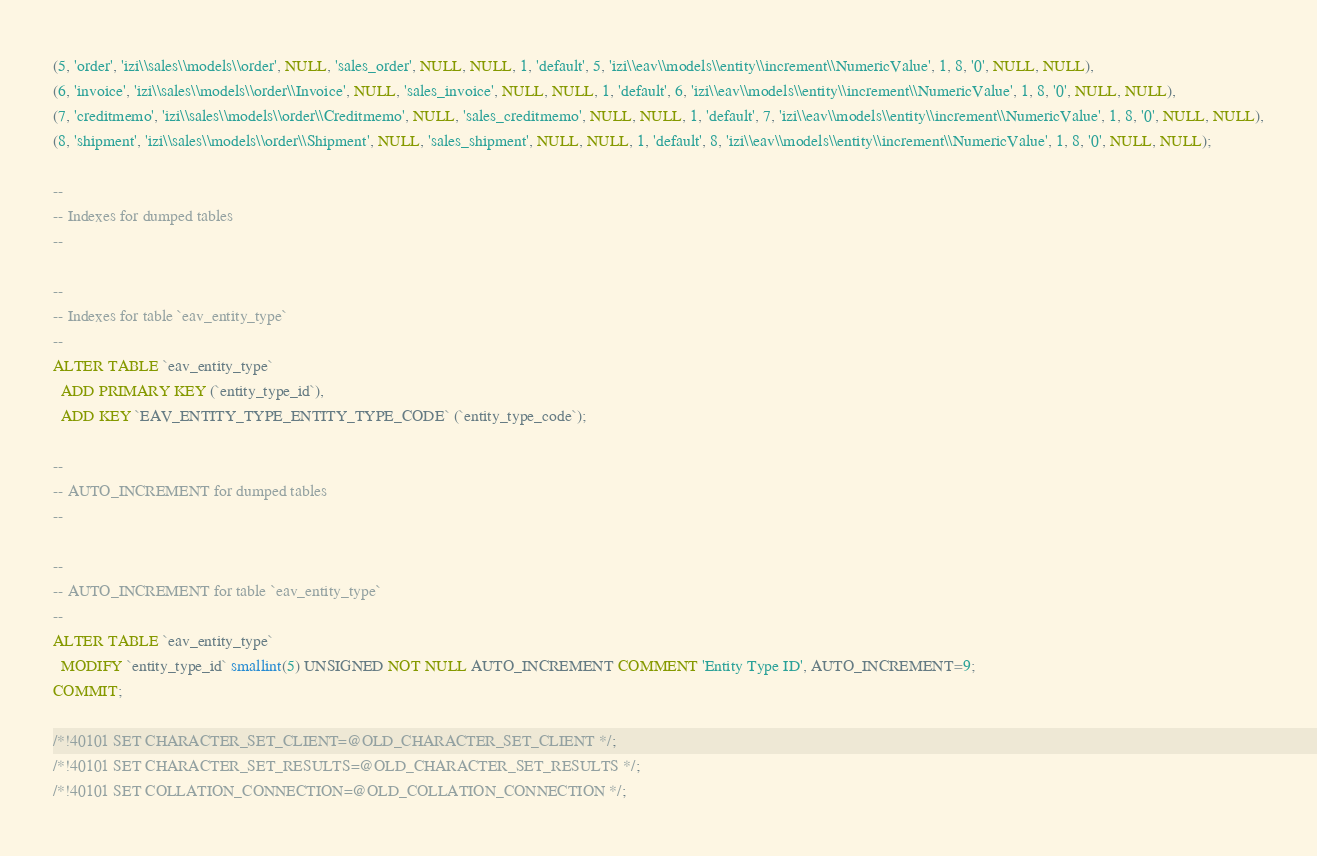<code> <loc_0><loc_0><loc_500><loc_500><_SQL_>(5, 'order', 'izi\\sales\\models\\order', NULL, 'sales_order', NULL, NULL, 1, 'default', 5, 'izi\\eav\\models\\entity\\increment\\NumericValue', 1, 8, '0', NULL, NULL),
(6, 'invoice', 'izi\\sales\\models\\order\\Invoice', NULL, 'sales_invoice', NULL, NULL, 1, 'default', 6, 'izi\\eav\\models\\entity\\increment\\NumericValue', 1, 8, '0', NULL, NULL),
(7, 'creditmemo', 'izi\\sales\\models\\order\\Creditmemo', NULL, 'sales_creditmemo', NULL, NULL, 1, 'default', 7, 'izi\\eav\\models\\entity\\increment\\NumericValue', 1, 8, '0', NULL, NULL),
(8, 'shipment', 'izi\\sales\\models\\order\\Shipment', NULL, 'sales_shipment', NULL, NULL, 1, 'default', 8, 'izi\\eav\\models\\entity\\increment\\NumericValue', 1, 8, '0', NULL, NULL);

--
-- Indexes for dumped tables
--

--
-- Indexes for table `eav_entity_type`
--
ALTER TABLE `eav_entity_type`
  ADD PRIMARY KEY (`entity_type_id`),
  ADD KEY `EAV_ENTITY_TYPE_ENTITY_TYPE_CODE` (`entity_type_code`);

--
-- AUTO_INCREMENT for dumped tables
--

--
-- AUTO_INCREMENT for table `eav_entity_type`
--
ALTER TABLE `eav_entity_type`
  MODIFY `entity_type_id` smallint(5) UNSIGNED NOT NULL AUTO_INCREMENT COMMENT 'Entity Type ID', AUTO_INCREMENT=9;
COMMIT;

/*!40101 SET CHARACTER_SET_CLIENT=@OLD_CHARACTER_SET_CLIENT */;
/*!40101 SET CHARACTER_SET_RESULTS=@OLD_CHARACTER_SET_RESULTS */;
/*!40101 SET COLLATION_CONNECTION=@OLD_COLLATION_CONNECTION */;
</code> 